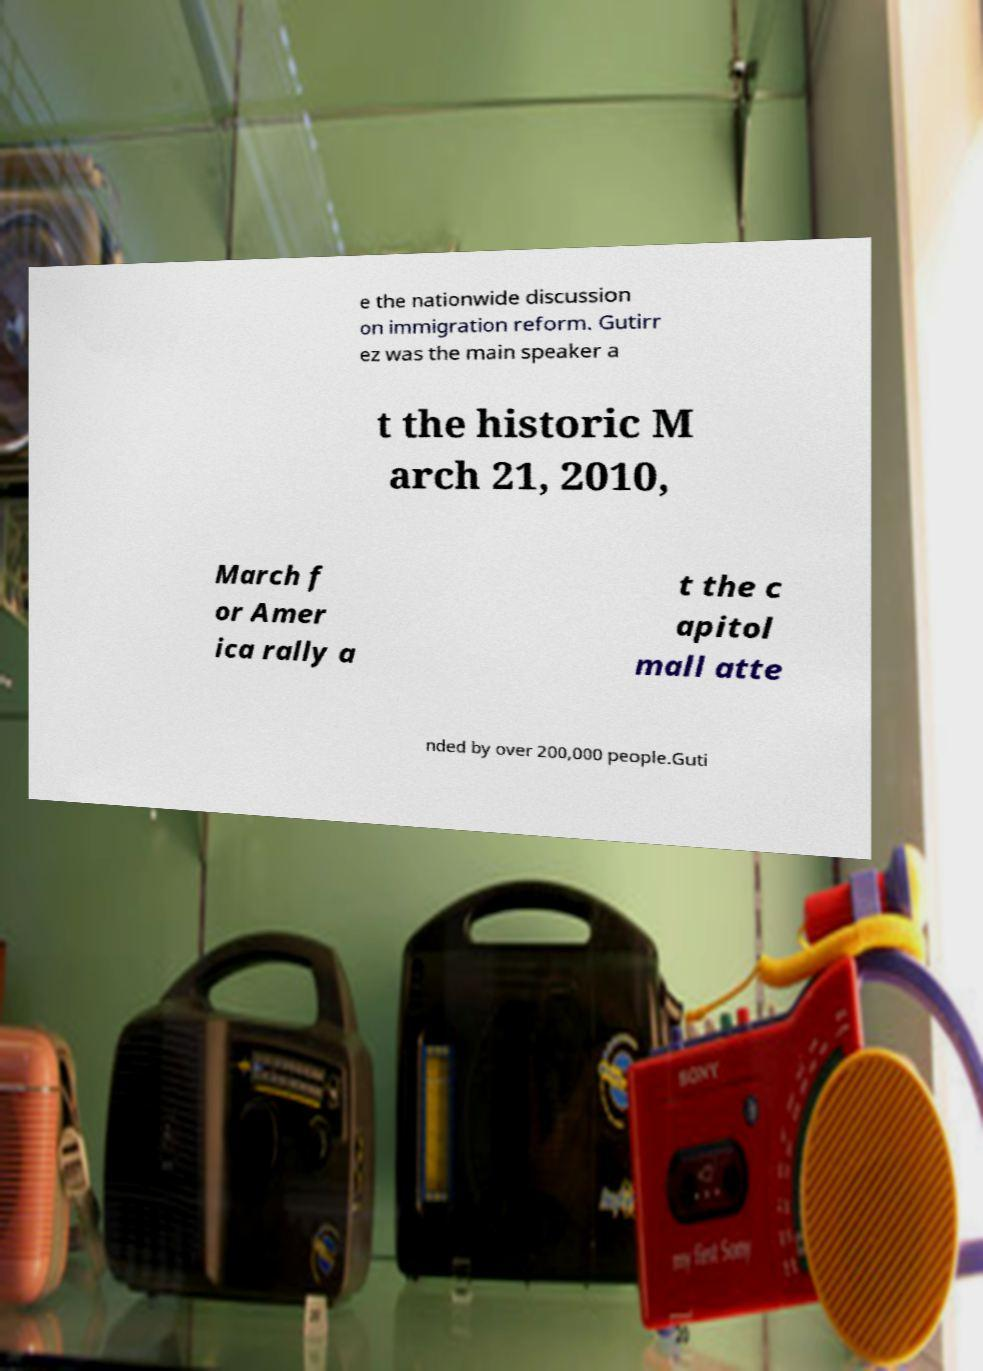Can you read and provide the text displayed in the image?This photo seems to have some interesting text. Can you extract and type it out for me? e the nationwide discussion on immigration reform. Gutirr ez was the main speaker a t the historic M arch 21, 2010, March f or Amer ica rally a t the c apitol mall atte nded by over 200,000 people.Guti 